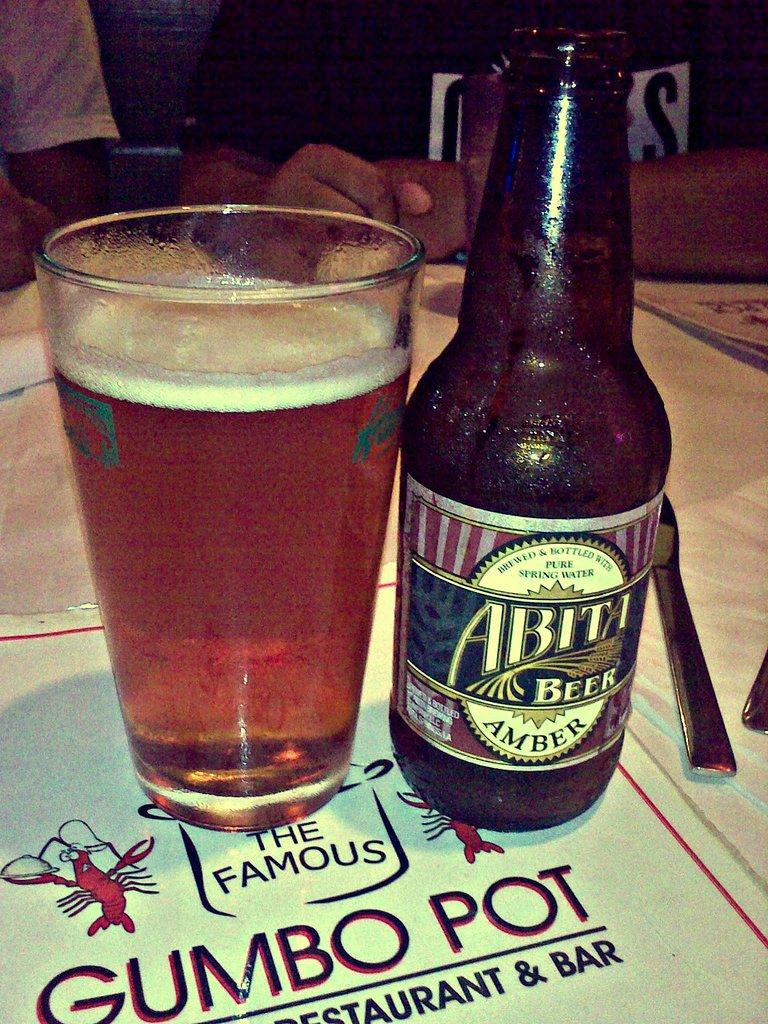<image>
Describe the image concisely. A glass and bottle of Abita Beer on top of a menu for the Famous Gumbo Pot Restaurant 